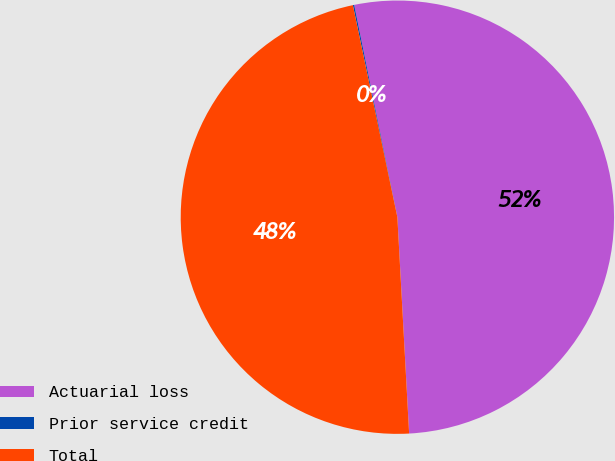<chart> <loc_0><loc_0><loc_500><loc_500><pie_chart><fcel>Actuarial loss<fcel>Prior service credit<fcel>Total<nl><fcel>52.33%<fcel>0.1%<fcel>47.57%<nl></chart> 